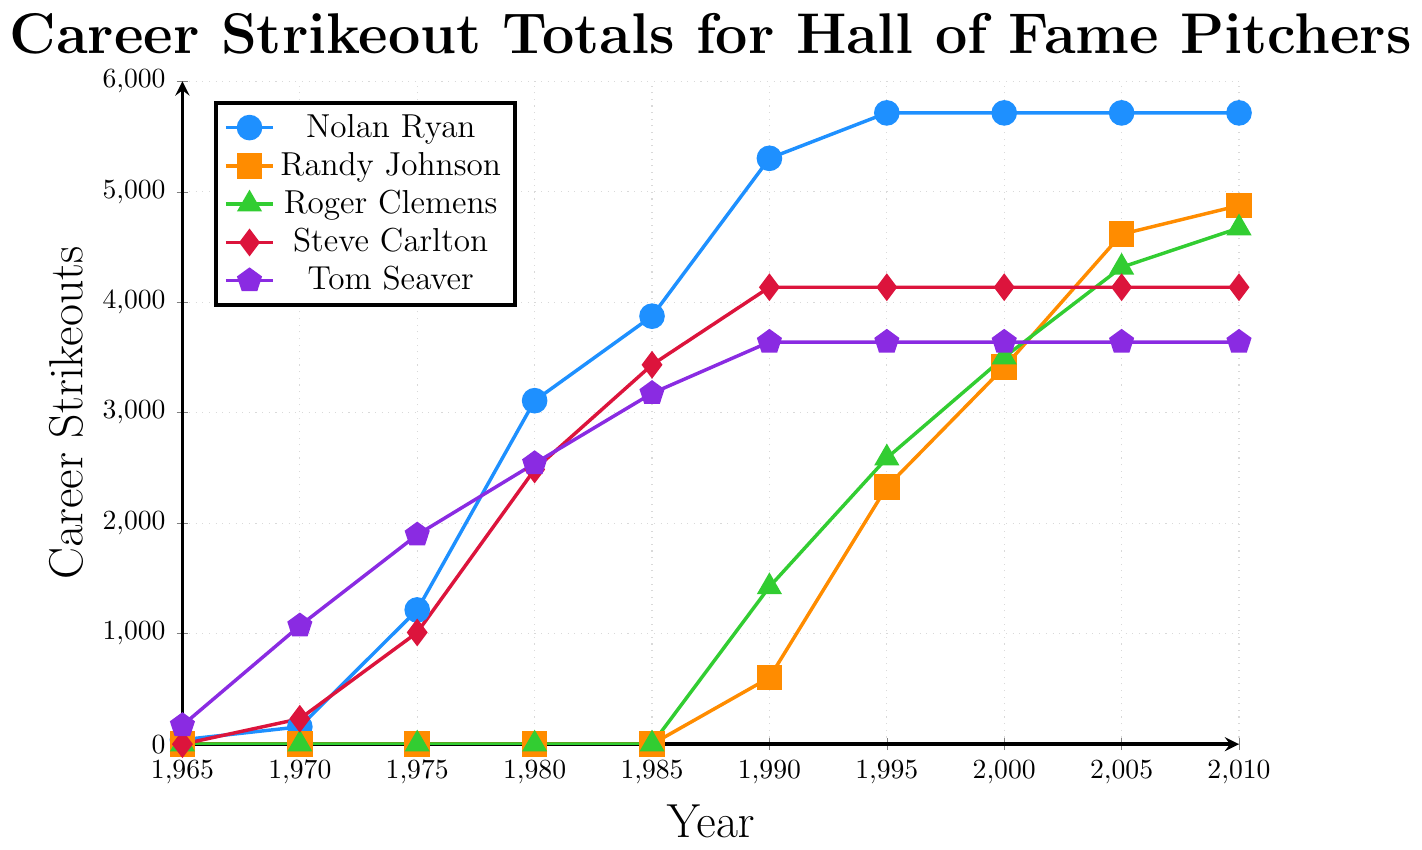Which pitcher had the highest career strikeout total by 2010? Nolan Ryan's curve reaches the highest point first by 2010, topping out at 5714 strikeouts.
Answer: Nolan Ryan Which pitcher had accumulated the least career strikeouts by 1990? By 1990, Randy Johnson is just beginning his career with 602 strikeouts, which is the least compared to others at that time.
Answer: Randy Johnson What's the difference in career strikeouts between Nolan Ryan and Randy Johnson by 2000? Nolan Ryan has 5714 strikeouts in 2000, whereas Randy Johnson has 3412. The difference is 5714 - 3412 = 2302.
Answer: 2302 How many strikeouts did Tom Seaver achieve by 1980, and how much more did he have by 1985? Tom Seaver had 2541 strikeouts by 1980 and 3176 by 1985. The increase is 3176 - 2541 = 635.
Answer: 635 Compare the career strikeout totals of Steve Carlton and Roger Clemens by 2005. Who had more? In 2005, Steve Carlton's strikeout total is flat at 4136, while Roger Clemens reaches 4317. Roger Clemens had more.
Answer: Roger Clemens By how many strikeouts did Nolan Ryan lead Roger Clemens in 1995? Nolan Ryan's total in 1995 is 5714, whereas Roger Clemens has 2590. The difference is 5714 - 2590 = 3124.
Answer: 3124 What is the total sum of strikeouts for Nolan Ryan and Steve Carlton by 1980? Nolan Ryan has 3109 and Steve Carlton has 2486 by 1980. Total is 3109 + 2486 = 5595.
Answer: 5595 Which two pitchers had the same strikeout totals between 1995-2010? Between 1995-2010, Steve Carlton and Tom Seaver both have strikeout totals that level off, remaining unchanged at 4136 and 3640 respectively.
Answer: Steve Carlton, Tom Seaver By how much did Randy Johnson's strikeouts increase from 1990 to 2000? Randy Johnson's increase from 602 in 1990 to 3412 in 2000 can be calculated as 3412 - 602 = 2810.
Answer: 2810 What is the trend of Nolan Ryan's career strikeouts from 1985 to 2010? Nolan Ryan's career strikeouts increase sharply from 1985 (3874) to 1990 (5303) and then plateau at 5714, maintaining this total through 2010, reflecting a rapid peak followed by no change.
Answer: Rapid rise, then plateau 